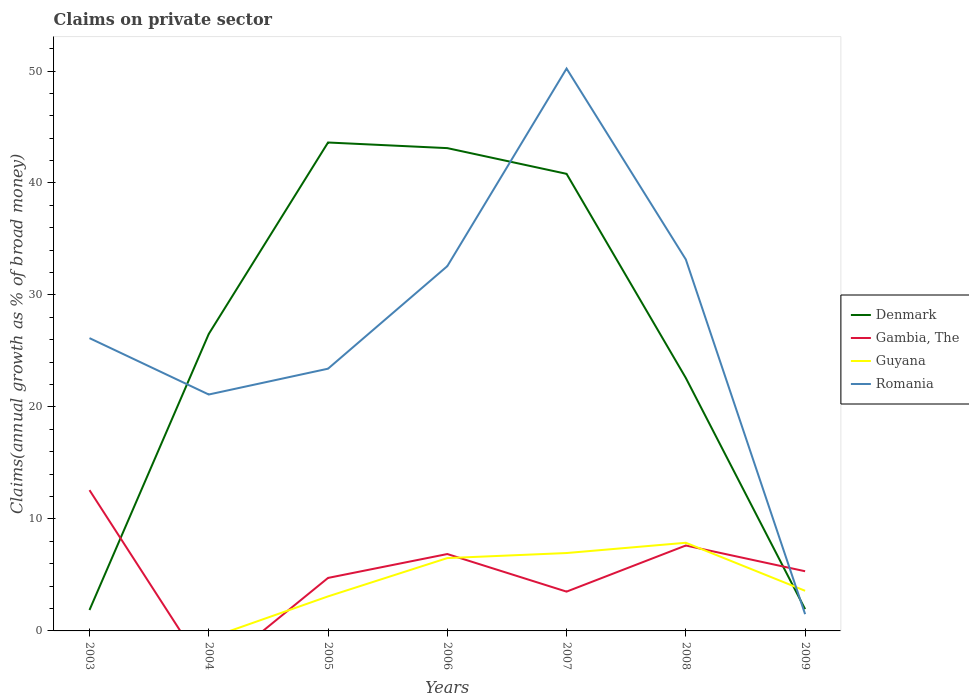Does the line corresponding to Guyana intersect with the line corresponding to Denmark?
Offer a terse response. Yes. Across all years, what is the maximum percentage of broad money claimed on private sector in Gambia, The?
Your answer should be compact. 0. What is the total percentage of broad money claimed on private sector in Denmark in the graph?
Provide a succinct answer. -17.1. What is the difference between the highest and the second highest percentage of broad money claimed on private sector in Romania?
Your answer should be very brief. 48.72. Is the percentage of broad money claimed on private sector in Guyana strictly greater than the percentage of broad money claimed on private sector in Romania over the years?
Your answer should be compact. No. How many years are there in the graph?
Give a very brief answer. 7. What is the difference between two consecutive major ticks on the Y-axis?
Provide a succinct answer. 10. Are the values on the major ticks of Y-axis written in scientific E-notation?
Your answer should be very brief. No. Does the graph contain any zero values?
Your response must be concise. Yes. Does the graph contain grids?
Your response must be concise. No. Where does the legend appear in the graph?
Provide a short and direct response. Center right. How are the legend labels stacked?
Keep it short and to the point. Vertical. What is the title of the graph?
Provide a succinct answer. Claims on private sector. What is the label or title of the Y-axis?
Your answer should be very brief. Claims(annual growth as % of broad money). What is the Claims(annual growth as % of broad money) in Denmark in 2003?
Give a very brief answer. 1.87. What is the Claims(annual growth as % of broad money) of Gambia, The in 2003?
Give a very brief answer. 12.57. What is the Claims(annual growth as % of broad money) of Romania in 2003?
Offer a very short reply. 26.15. What is the Claims(annual growth as % of broad money) of Denmark in 2004?
Offer a terse response. 26.52. What is the Claims(annual growth as % of broad money) of Romania in 2004?
Give a very brief answer. 21.11. What is the Claims(annual growth as % of broad money) of Denmark in 2005?
Ensure brevity in your answer.  43.62. What is the Claims(annual growth as % of broad money) of Gambia, The in 2005?
Ensure brevity in your answer.  4.73. What is the Claims(annual growth as % of broad money) in Guyana in 2005?
Your response must be concise. 3.08. What is the Claims(annual growth as % of broad money) of Romania in 2005?
Provide a short and direct response. 23.42. What is the Claims(annual growth as % of broad money) of Denmark in 2006?
Your response must be concise. 43.11. What is the Claims(annual growth as % of broad money) in Gambia, The in 2006?
Offer a terse response. 6.87. What is the Claims(annual growth as % of broad money) of Guyana in 2006?
Ensure brevity in your answer.  6.5. What is the Claims(annual growth as % of broad money) in Romania in 2006?
Provide a succinct answer. 32.57. What is the Claims(annual growth as % of broad money) of Denmark in 2007?
Ensure brevity in your answer.  40.82. What is the Claims(annual growth as % of broad money) in Gambia, The in 2007?
Your answer should be very brief. 3.51. What is the Claims(annual growth as % of broad money) in Guyana in 2007?
Your answer should be very brief. 6.96. What is the Claims(annual growth as % of broad money) in Romania in 2007?
Your response must be concise. 50.22. What is the Claims(annual growth as % of broad money) in Denmark in 2008?
Offer a very short reply. 22.59. What is the Claims(annual growth as % of broad money) of Gambia, The in 2008?
Offer a very short reply. 7.63. What is the Claims(annual growth as % of broad money) in Guyana in 2008?
Your response must be concise. 7.87. What is the Claims(annual growth as % of broad money) in Romania in 2008?
Offer a very short reply. 33.17. What is the Claims(annual growth as % of broad money) of Denmark in 2009?
Your answer should be compact. 1.94. What is the Claims(annual growth as % of broad money) in Gambia, The in 2009?
Your answer should be compact. 5.33. What is the Claims(annual growth as % of broad money) of Guyana in 2009?
Offer a very short reply. 3.58. What is the Claims(annual growth as % of broad money) in Romania in 2009?
Provide a short and direct response. 1.5. Across all years, what is the maximum Claims(annual growth as % of broad money) in Denmark?
Keep it short and to the point. 43.62. Across all years, what is the maximum Claims(annual growth as % of broad money) in Gambia, The?
Ensure brevity in your answer.  12.57. Across all years, what is the maximum Claims(annual growth as % of broad money) of Guyana?
Give a very brief answer. 7.87. Across all years, what is the maximum Claims(annual growth as % of broad money) in Romania?
Offer a terse response. 50.22. Across all years, what is the minimum Claims(annual growth as % of broad money) of Denmark?
Make the answer very short. 1.87. Across all years, what is the minimum Claims(annual growth as % of broad money) in Gambia, The?
Provide a succinct answer. 0. Across all years, what is the minimum Claims(annual growth as % of broad money) in Guyana?
Your response must be concise. 0. Across all years, what is the minimum Claims(annual growth as % of broad money) in Romania?
Offer a terse response. 1.5. What is the total Claims(annual growth as % of broad money) in Denmark in the graph?
Keep it short and to the point. 180.47. What is the total Claims(annual growth as % of broad money) in Gambia, The in the graph?
Provide a succinct answer. 40.64. What is the total Claims(annual growth as % of broad money) of Guyana in the graph?
Provide a short and direct response. 28. What is the total Claims(annual growth as % of broad money) of Romania in the graph?
Offer a very short reply. 188.13. What is the difference between the Claims(annual growth as % of broad money) in Denmark in 2003 and that in 2004?
Your answer should be compact. -24.65. What is the difference between the Claims(annual growth as % of broad money) in Romania in 2003 and that in 2004?
Ensure brevity in your answer.  5.04. What is the difference between the Claims(annual growth as % of broad money) of Denmark in 2003 and that in 2005?
Your answer should be very brief. -41.75. What is the difference between the Claims(annual growth as % of broad money) of Gambia, The in 2003 and that in 2005?
Offer a terse response. 7.84. What is the difference between the Claims(annual growth as % of broad money) in Romania in 2003 and that in 2005?
Offer a very short reply. 2.73. What is the difference between the Claims(annual growth as % of broad money) in Denmark in 2003 and that in 2006?
Offer a terse response. -41.25. What is the difference between the Claims(annual growth as % of broad money) in Gambia, The in 2003 and that in 2006?
Give a very brief answer. 5.71. What is the difference between the Claims(annual growth as % of broad money) of Romania in 2003 and that in 2006?
Your answer should be compact. -6.43. What is the difference between the Claims(annual growth as % of broad money) of Denmark in 2003 and that in 2007?
Offer a terse response. -38.95. What is the difference between the Claims(annual growth as % of broad money) in Gambia, The in 2003 and that in 2007?
Ensure brevity in your answer.  9.06. What is the difference between the Claims(annual growth as % of broad money) of Romania in 2003 and that in 2007?
Give a very brief answer. -24.07. What is the difference between the Claims(annual growth as % of broad money) in Denmark in 2003 and that in 2008?
Give a very brief answer. -20.72. What is the difference between the Claims(annual growth as % of broad money) in Gambia, The in 2003 and that in 2008?
Your answer should be very brief. 4.94. What is the difference between the Claims(annual growth as % of broad money) in Romania in 2003 and that in 2008?
Your response must be concise. -7.02. What is the difference between the Claims(annual growth as % of broad money) in Denmark in 2003 and that in 2009?
Give a very brief answer. -0.08. What is the difference between the Claims(annual growth as % of broad money) of Gambia, The in 2003 and that in 2009?
Provide a short and direct response. 7.24. What is the difference between the Claims(annual growth as % of broad money) in Romania in 2003 and that in 2009?
Ensure brevity in your answer.  24.65. What is the difference between the Claims(annual growth as % of broad money) of Denmark in 2004 and that in 2005?
Your answer should be compact. -17.1. What is the difference between the Claims(annual growth as % of broad money) in Romania in 2004 and that in 2005?
Keep it short and to the point. -2.31. What is the difference between the Claims(annual growth as % of broad money) in Denmark in 2004 and that in 2006?
Your answer should be very brief. -16.59. What is the difference between the Claims(annual growth as % of broad money) of Romania in 2004 and that in 2006?
Give a very brief answer. -11.46. What is the difference between the Claims(annual growth as % of broad money) in Denmark in 2004 and that in 2007?
Give a very brief answer. -14.3. What is the difference between the Claims(annual growth as % of broad money) of Romania in 2004 and that in 2007?
Give a very brief answer. -29.11. What is the difference between the Claims(annual growth as % of broad money) in Denmark in 2004 and that in 2008?
Make the answer very short. 3.93. What is the difference between the Claims(annual growth as % of broad money) in Romania in 2004 and that in 2008?
Your response must be concise. -12.06. What is the difference between the Claims(annual growth as % of broad money) of Denmark in 2004 and that in 2009?
Keep it short and to the point. 24.58. What is the difference between the Claims(annual growth as % of broad money) of Romania in 2004 and that in 2009?
Make the answer very short. 19.61. What is the difference between the Claims(annual growth as % of broad money) of Denmark in 2005 and that in 2006?
Your answer should be compact. 0.5. What is the difference between the Claims(annual growth as % of broad money) in Gambia, The in 2005 and that in 2006?
Give a very brief answer. -2.13. What is the difference between the Claims(annual growth as % of broad money) of Guyana in 2005 and that in 2006?
Your response must be concise. -3.42. What is the difference between the Claims(annual growth as % of broad money) of Romania in 2005 and that in 2006?
Offer a very short reply. -9.16. What is the difference between the Claims(annual growth as % of broad money) of Denmark in 2005 and that in 2007?
Your response must be concise. 2.8. What is the difference between the Claims(annual growth as % of broad money) of Gambia, The in 2005 and that in 2007?
Ensure brevity in your answer.  1.22. What is the difference between the Claims(annual growth as % of broad money) of Guyana in 2005 and that in 2007?
Offer a very short reply. -3.87. What is the difference between the Claims(annual growth as % of broad money) of Romania in 2005 and that in 2007?
Your answer should be very brief. -26.8. What is the difference between the Claims(annual growth as % of broad money) of Denmark in 2005 and that in 2008?
Provide a succinct answer. 21.03. What is the difference between the Claims(annual growth as % of broad money) in Gambia, The in 2005 and that in 2008?
Offer a very short reply. -2.9. What is the difference between the Claims(annual growth as % of broad money) in Guyana in 2005 and that in 2008?
Make the answer very short. -4.79. What is the difference between the Claims(annual growth as % of broad money) of Romania in 2005 and that in 2008?
Make the answer very short. -9.75. What is the difference between the Claims(annual growth as % of broad money) of Denmark in 2005 and that in 2009?
Your response must be concise. 41.67. What is the difference between the Claims(annual growth as % of broad money) in Gambia, The in 2005 and that in 2009?
Provide a succinct answer. -0.6. What is the difference between the Claims(annual growth as % of broad money) in Guyana in 2005 and that in 2009?
Your response must be concise. -0.5. What is the difference between the Claims(annual growth as % of broad money) of Romania in 2005 and that in 2009?
Provide a succinct answer. 21.92. What is the difference between the Claims(annual growth as % of broad money) of Denmark in 2006 and that in 2007?
Your answer should be very brief. 2.3. What is the difference between the Claims(annual growth as % of broad money) in Gambia, The in 2006 and that in 2007?
Give a very brief answer. 3.36. What is the difference between the Claims(annual growth as % of broad money) in Guyana in 2006 and that in 2007?
Provide a succinct answer. -0.45. What is the difference between the Claims(annual growth as % of broad money) of Romania in 2006 and that in 2007?
Your response must be concise. -17.65. What is the difference between the Claims(annual growth as % of broad money) in Denmark in 2006 and that in 2008?
Provide a succinct answer. 20.53. What is the difference between the Claims(annual growth as % of broad money) of Gambia, The in 2006 and that in 2008?
Keep it short and to the point. -0.76. What is the difference between the Claims(annual growth as % of broad money) in Guyana in 2006 and that in 2008?
Keep it short and to the point. -1.37. What is the difference between the Claims(annual growth as % of broad money) in Romania in 2006 and that in 2008?
Ensure brevity in your answer.  -0.6. What is the difference between the Claims(annual growth as % of broad money) of Denmark in 2006 and that in 2009?
Your answer should be compact. 41.17. What is the difference between the Claims(annual growth as % of broad money) in Gambia, The in 2006 and that in 2009?
Keep it short and to the point. 1.54. What is the difference between the Claims(annual growth as % of broad money) in Guyana in 2006 and that in 2009?
Offer a very short reply. 2.92. What is the difference between the Claims(annual growth as % of broad money) of Romania in 2006 and that in 2009?
Make the answer very short. 31.08. What is the difference between the Claims(annual growth as % of broad money) of Denmark in 2007 and that in 2008?
Give a very brief answer. 18.23. What is the difference between the Claims(annual growth as % of broad money) in Gambia, The in 2007 and that in 2008?
Provide a short and direct response. -4.12. What is the difference between the Claims(annual growth as % of broad money) in Guyana in 2007 and that in 2008?
Provide a succinct answer. -0.92. What is the difference between the Claims(annual growth as % of broad money) in Romania in 2007 and that in 2008?
Your answer should be compact. 17.05. What is the difference between the Claims(annual growth as % of broad money) of Denmark in 2007 and that in 2009?
Your answer should be very brief. 38.87. What is the difference between the Claims(annual growth as % of broad money) of Gambia, The in 2007 and that in 2009?
Your answer should be very brief. -1.82. What is the difference between the Claims(annual growth as % of broad money) of Guyana in 2007 and that in 2009?
Your answer should be compact. 3.37. What is the difference between the Claims(annual growth as % of broad money) in Romania in 2007 and that in 2009?
Make the answer very short. 48.72. What is the difference between the Claims(annual growth as % of broad money) of Denmark in 2008 and that in 2009?
Offer a terse response. 20.64. What is the difference between the Claims(annual growth as % of broad money) in Gambia, The in 2008 and that in 2009?
Offer a very short reply. 2.3. What is the difference between the Claims(annual growth as % of broad money) of Guyana in 2008 and that in 2009?
Offer a very short reply. 4.29. What is the difference between the Claims(annual growth as % of broad money) of Romania in 2008 and that in 2009?
Your response must be concise. 31.67. What is the difference between the Claims(annual growth as % of broad money) of Denmark in 2003 and the Claims(annual growth as % of broad money) of Romania in 2004?
Your answer should be compact. -19.24. What is the difference between the Claims(annual growth as % of broad money) in Gambia, The in 2003 and the Claims(annual growth as % of broad money) in Romania in 2004?
Give a very brief answer. -8.54. What is the difference between the Claims(annual growth as % of broad money) in Denmark in 2003 and the Claims(annual growth as % of broad money) in Gambia, The in 2005?
Provide a short and direct response. -2.86. What is the difference between the Claims(annual growth as % of broad money) of Denmark in 2003 and the Claims(annual growth as % of broad money) of Guyana in 2005?
Offer a terse response. -1.22. What is the difference between the Claims(annual growth as % of broad money) of Denmark in 2003 and the Claims(annual growth as % of broad money) of Romania in 2005?
Offer a very short reply. -21.55. What is the difference between the Claims(annual growth as % of broad money) of Gambia, The in 2003 and the Claims(annual growth as % of broad money) of Guyana in 2005?
Keep it short and to the point. 9.49. What is the difference between the Claims(annual growth as % of broad money) of Gambia, The in 2003 and the Claims(annual growth as % of broad money) of Romania in 2005?
Offer a very short reply. -10.84. What is the difference between the Claims(annual growth as % of broad money) in Denmark in 2003 and the Claims(annual growth as % of broad money) in Gambia, The in 2006?
Keep it short and to the point. -5. What is the difference between the Claims(annual growth as % of broad money) in Denmark in 2003 and the Claims(annual growth as % of broad money) in Guyana in 2006?
Make the answer very short. -4.64. What is the difference between the Claims(annual growth as % of broad money) of Denmark in 2003 and the Claims(annual growth as % of broad money) of Romania in 2006?
Offer a very short reply. -30.7. What is the difference between the Claims(annual growth as % of broad money) in Gambia, The in 2003 and the Claims(annual growth as % of broad money) in Guyana in 2006?
Provide a succinct answer. 6.07. What is the difference between the Claims(annual growth as % of broad money) of Gambia, The in 2003 and the Claims(annual growth as % of broad money) of Romania in 2006?
Your answer should be very brief. -20. What is the difference between the Claims(annual growth as % of broad money) in Denmark in 2003 and the Claims(annual growth as % of broad money) in Gambia, The in 2007?
Offer a very short reply. -1.64. What is the difference between the Claims(annual growth as % of broad money) of Denmark in 2003 and the Claims(annual growth as % of broad money) of Guyana in 2007?
Offer a terse response. -5.09. What is the difference between the Claims(annual growth as % of broad money) of Denmark in 2003 and the Claims(annual growth as % of broad money) of Romania in 2007?
Provide a short and direct response. -48.35. What is the difference between the Claims(annual growth as % of broad money) of Gambia, The in 2003 and the Claims(annual growth as % of broad money) of Guyana in 2007?
Ensure brevity in your answer.  5.62. What is the difference between the Claims(annual growth as % of broad money) of Gambia, The in 2003 and the Claims(annual growth as % of broad money) of Romania in 2007?
Offer a very short reply. -37.65. What is the difference between the Claims(annual growth as % of broad money) of Denmark in 2003 and the Claims(annual growth as % of broad money) of Gambia, The in 2008?
Ensure brevity in your answer.  -5.76. What is the difference between the Claims(annual growth as % of broad money) of Denmark in 2003 and the Claims(annual growth as % of broad money) of Guyana in 2008?
Keep it short and to the point. -6. What is the difference between the Claims(annual growth as % of broad money) of Denmark in 2003 and the Claims(annual growth as % of broad money) of Romania in 2008?
Keep it short and to the point. -31.3. What is the difference between the Claims(annual growth as % of broad money) in Gambia, The in 2003 and the Claims(annual growth as % of broad money) in Guyana in 2008?
Give a very brief answer. 4.7. What is the difference between the Claims(annual growth as % of broad money) of Gambia, The in 2003 and the Claims(annual growth as % of broad money) of Romania in 2008?
Ensure brevity in your answer.  -20.6. What is the difference between the Claims(annual growth as % of broad money) in Denmark in 2003 and the Claims(annual growth as % of broad money) in Gambia, The in 2009?
Your answer should be very brief. -3.46. What is the difference between the Claims(annual growth as % of broad money) in Denmark in 2003 and the Claims(annual growth as % of broad money) in Guyana in 2009?
Your response must be concise. -1.72. What is the difference between the Claims(annual growth as % of broad money) in Denmark in 2003 and the Claims(annual growth as % of broad money) in Romania in 2009?
Provide a succinct answer. 0.37. What is the difference between the Claims(annual growth as % of broad money) of Gambia, The in 2003 and the Claims(annual growth as % of broad money) of Guyana in 2009?
Offer a very short reply. 8.99. What is the difference between the Claims(annual growth as % of broad money) in Gambia, The in 2003 and the Claims(annual growth as % of broad money) in Romania in 2009?
Make the answer very short. 11.08. What is the difference between the Claims(annual growth as % of broad money) of Denmark in 2004 and the Claims(annual growth as % of broad money) of Gambia, The in 2005?
Keep it short and to the point. 21.79. What is the difference between the Claims(annual growth as % of broad money) of Denmark in 2004 and the Claims(annual growth as % of broad money) of Guyana in 2005?
Offer a very short reply. 23.44. What is the difference between the Claims(annual growth as % of broad money) of Denmark in 2004 and the Claims(annual growth as % of broad money) of Romania in 2005?
Your response must be concise. 3.1. What is the difference between the Claims(annual growth as % of broad money) of Denmark in 2004 and the Claims(annual growth as % of broad money) of Gambia, The in 2006?
Offer a terse response. 19.65. What is the difference between the Claims(annual growth as % of broad money) in Denmark in 2004 and the Claims(annual growth as % of broad money) in Guyana in 2006?
Ensure brevity in your answer.  20.02. What is the difference between the Claims(annual growth as % of broad money) in Denmark in 2004 and the Claims(annual growth as % of broad money) in Romania in 2006?
Keep it short and to the point. -6.05. What is the difference between the Claims(annual growth as % of broad money) of Denmark in 2004 and the Claims(annual growth as % of broad money) of Gambia, The in 2007?
Offer a terse response. 23.01. What is the difference between the Claims(annual growth as % of broad money) of Denmark in 2004 and the Claims(annual growth as % of broad money) of Guyana in 2007?
Your answer should be very brief. 19.56. What is the difference between the Claims(annual growth as % of broad money) of Denmark in 2004 and the Claims(annual growth as % of broad money) of Romania in 2007?
Keep it short and to the point. -23.7. What is the difference between the Claims(annual growth as % of broad money) of Denmark in 2004 and the Claims(annual growth as % of broad money) of Gambia, The in 2008?
Provide a succinct answer. 18.89. What is the difference between the Claims(annual growth as % of broad money) in Denmark in 2004 and the Claims(annual growth as % of broad money) in Guyana in 2008?
Offer a terse response. 18.65. What is the difference between the Claims(annual growth as % of broad money) in Denmark in 2004 and the Claims(annual growth as % of broad money) in Romania in 2008?
Offer a very short reply. -6.65. What is the difference between the Claims(annual growth as % of broad money) of Denmark in 2004 and the Claims(annual growth as % of broad money) of Gambia, The in 2009?
Ensure brevity in your answer.  21.19. What is the difference between the Claims(annual growth as % of broad money) in Denmark in 2004 and the Claims(annual growth as % of broad money) in Guyana in 2009?
Offer a very short reply. 22.94. What is the difference between the Claims(annual growth as % of broad money) in Denmark in 2004 and the Claims(annual growth as % of broad money) in Romania in 2009?
Make the answer very short. 25.02. What is the difference between the Claims(annual growth as % of broad money) of Denmark in 2005 and the Claims(annual growth as % of broad money) of Gambia, The in 2006?
Make the answer very short. 36.75. What is the difference between the Claims(annual growth as % of broad money) of Denmark in 2005 and the Claims(annual growth as % of broad money) of Guyana in 2006?
Offer a very short reply. 37.11. What is the difference between the Claims(annual growth as % of broad money) in Denmark in 2005 and the Claims(annual growth as % of broad money) in Romania in 2006?
Offer a terse response. 11.04. What is the difference between the Claims(annual growth as % of broad money) in Gambia, The in 2005 and the Claims(annual growth as % of broad money) in Guyana in 2006?
Offer a terse response. -1.77. What is the difference between the Claims(annual growth as % of broad money) in Gambia, The in 2005 and the Claims(annual growth as % of broad money) in Romania in 2006?
Keep it short and to the point. -27.84. What is the difference between the Claims(annual growth as % of broad money) in Guyana in 2005 and the Claims(annual growth as % of broad money) in Romania in 2006?
Your answer should be very brief. -29.49. What is the difference between the Claims(annual growth as % of broad money) in Denmark in 2005 and the Claims(annual growth as % of broad money) in Gambia, The in 2007?
Your response must be concise. 40.11. What is the difference between the Claims(annual growth as % of broad money) of Denmark in 2005 and the Claims(annual growth as % of broad money) of Guyana in 2007?
Keep it short and to the point. 36.66. What is the difference between the Claims(annual growth as % of broad money) in Denmark in 2005 and the Claims(annual growth as % of broad money) in Romania in 2007?
Offer a terse response. -6.6. What is the difference between the Claims(annual growth as % of broad money) in Gambia, The in 2005 and the Claims(annual growth as % of broad money) in Guyana in 2007?
Keep it short and to the point. -2.22. What is the difference between the Claims(annual growth as % of broad money) of Gambia, The in 2005 and the Claims(annual growth as % of broad money) of Romania in 2007?
Provide a short and direct response. -45.49. What is the difference between the Claims(annual growth as % of broad money) in Guyana in 2005 and the Claims(annual growth as % of broad money) in Romania in 2007?
Provide a succinct answer. -47.14. What is the difference between the Claims(annual growth as % of broad money) in Denmark in 2005 and the Claims(annual growth as % of broad money) in Gambia, The in 2008?
Your answer should be very brief. 35.99. What is the difference between the Claims(annual growth as % of broad money) in Denmark in 2005 and the Claims(annual growth as % of broad money) in Guyana in 2008?
Give a very brief answer. 35.74. What is the difference between the Claims(annual growth as % of broad money) of Denmark in 2005 and the Claims(annual growth as % of broad money) of Romania in 2008?
Offer a terse response. 10.45. What is the difference between the Claims(annual growth as % of broad money) in Gambia, The in 2005 and the Claims(annual growth as % of broad money) in Guyana in 2008?
Provide a short and direct response. -3.14. What is the difference between the Claims(annual growth as % of broad money) of Gambia, The in 2005 and the Claims(annual growth as % of broad money) of Romania in 2008?
Your answer should be very brief. -28.44. What is the difference between the Claims(annual growth as % of broad money) in Guyana in 2005 and the Claims(annual growth as % of broad money) in Romania in 2008?
Give a very brief answer. -30.09. What is the difference between the Claims(annual growth as % of broad money) of Denmark in 2005 and the Claims(annual growth as % of broad money) of Gambia, The in 2009?
Provide a short and direct response. 38.29. What is the difference between the Claims(annual growth as % of broad money) in Denmark in 2005 and the Claims(annual growth as % of broad money) in Guyana in 2009?
Offer a terse response. 40.03. What is the difference between the Claims(annual growth as % of broad money) of Denmark in 2005 and the Claims(annual growth as % of broad money) of Romania in 2009?
Provide a short and direct response. 42.12. What is the difference between the Claims(annual growth as % of broad money) in Gambia, The in 2005 and the Claims(annual growth as % of broad money) in Guyana in 2009?
Your answer should be very brief. 1.15. What is the difference between the Claims(annual growth as % of broad money) in Gambia, The in 2005 and the Claims(annual growth as % of broad money) in Romania in 2009?
Ensure brevity in your answer.  3.24. What is the difference between the Claims(annual growth as % of broad money) of Guyana in 2005 and the Claims(annual growth as % of broad money) of Romania in 2009?
Make the answer very short. 1.59. What is the difference between the Claims(annual growth as % of broad money) of Denmark in 2006 and the Claims(annual growth as % of broad money) of Gambia, The in 2007?
Your answer should be very brief. 39.6. What is the difference between the Claims(annual growth as % of broad money) of Denmark in 2006 and the Claims(annual growth as % of broad money) of Guyana in 2007?
Ensure brevity in your answer.  36.16. What is the difference between the Claims(annual growth as % of broad money) of Denmark in 2006 and the Claims(annual growth as % of broad money) of Romania in 2007?
Offer a terse response. -7.11. What is the difference between the Claims(annual growth as % of broad money) in Gambia, The in 2006 and the Claims(annual growth as % of broad money) in Guyana in 2007?
Provide a succinct answer. -0.09. What is the difference between the Claims(annual growth as % of broad money) in Gambia, The in 2006 and the Claims(annual growth as % of broad money) in Romania in 2007?
Offer a very short reply. -43.35. What is the difference between the Claims(annual growth as % of broad money) of Guyana in 2006 and the Claims(annual growth as % of broad money) of Romania in 2007?
Your answer should be compact. -43.72. What is the difference between the Claims(annual growth as % of broad money) of Denmark in 2006 and the Claims(annual growth as % of broad money) of Gambia, The in 2008?
Provide a short and direct response. 35.49. What is the difference between the Claims(annual growth as % of broad money) of Denmark in 2006 and the Claims(annual growth as % of broad money) of Guyana in 2008?
Keep it short and to the point. 35.24. What is the difference between the Claims(annual growth as % of broad money) in Denmark in 2006 and the Claims(annual growth as % of broad money) in Romania in 2008?
Your answer should be compact. 9.95. What is the difference between the Claims(annual growth as % of broad money) of Gambia, The in 2006 and the Claims(annual growth as % of broad money) of Guyana in 2008?
Provide a short and direct response. -1.01. What is the difference between the Claims(annual growth as % of broad money) of Gambia, The in 2006 and the Claims(annual growth as % of broad money) of Romania in 2008?
Offer a very short reply. -26.3. What is the difference between the Claims(annual growth as % of broad money) of Guyana in 2006 and the Claims(annual growth as % of broad money) of Romania in 2008?
Ensure brevity in your answer.  -26.66. What is the difference between the Claims(annual growth as % of broad money) of Denmark in 2006 and the Claims(annual growth as % of broad money) of Gambia, The in 2009?
Give a very brief answer. 37.78. What is the difference between the Claims(annual growth as % of broad money) of Denmark in 2006 and the Claims(annual growth as % of broad money) of Guyana in 2009?
Offer a very short reply. 39.53. What is the difference between the Claims(annual growth as % of broad money) of Denmark in 2006 and the Claims(annual growth as % of broad money) of Romania in 2009?
Ensure brevity in your answer.  41.62. What is the difference between the Claims(annual growth as % of broad money) in Gambia, The in 2006 and the Claims(annual growth as % of broad money) in Guyana in 2009?
Ensure brevity in your answer.  3.28. What is the difference between the Claims(annual growth as % of broad money) of Gambia, The in 2006 and the Claims(annual growth as % of broad money) of Romania in 2009?
Provide a short and direct response. 5.37. What is the difference between the Claims(annual growth as % of broad money) in Guyana in 2006 and the Claims(annual growth as % of broad money) in Romania in 2009?
Give a very brief answer. 5.01. What is the difference between the Claims(annual growth as % of broad money) of Denmark in 2007 and the Claims(annual growth as % of broad money) of Gambia, The in 2008?
Your answer should be compact. 33.19. What is the difference between the Claims(annual growth as % of broad money) of Denmark in 2007 and the Claims(annual growth as % of broad money) of Guyana in 2008?
Your answer should be compact. 32.95. What is the difference between the Claims(annual growth as % of broad money) of Denmark in 2007 and the Claims(annual growth as % of broad money) of Romania in 2008?
Keep it short and to the point. 7.65. What is the difference between the Claims(annual growth as % of broad money) in Gambia, The in 2007 and the Claims(annual growth as % of broad money) in Guyana in 2008?
Your answer should be compact. -4.36. What is the difference between the Claims(annual growth as % of broad money) of Gambia, The in 2007 and the Claims(annual growth as % of broad money) of Romania in 2008?
Your response must be concise. -29.66. What is the difference between the Claims(annual growth as % of broad money) in Guyana in 2007 and the Claims(annual growth as % of broad money) in Romania in 2008?
Offer a very short reply. -26.21. What is the difference between the Claims(annual growth as % of broad money) in Denmark in 2007 and the Claims(annual growth as % of broad money) in Gambia, The in 2009?
Your answer should be compact. 35.49. What is the difference between the Claims(annual growth as % of broad money) in Denmark in 2007 and the Claims(annual growth as % of broad money) in Guyana in 2009?
Make the answer very short. 37.23. What is the difference between the Claims(annual growth as % of broad money) in Denmark in 2007 and the Claims(annual growth as % of broad money) in Romania in 2009?
Offer a terse response. 39.32. What is the difference between the Claims(annual growth as % of broad money) of Gambia, The in 2007 and the Claims(annual growth as % of broad money) of Guyana in 2009?
Make the answer very short. -0.07. What is the difference between the Claims(annual growth as % of broad money) in Gambia, The in 2007 and the Claims(annual growth as % of broad money) in Romania in 2009?
Your answer should be compact. 2.01. What is the difference between the Claims(annual growth as % of broad money) in Guyana in 2007 and the Claims(annual growth as % of broad money) in Romania in 2009?
Give a very brief answer. 5.46. What is the difference between the Claims(annual growth as % of broad money) in Denmark in 2008 and the Claims(annual growth as % of broad money) in Gambia, The in 2009?
Keep it short and to the point. 17.26. What is the difference between the Claims(annual growth as % of broad money) of Denmark in 2008 and the Claims(annual growth as % of broad money) of Guyana in 2009?
Give a very brief answer. 19. What is the difference between the Claims(annual growth as % of broad money) of Denmark in 2008 and the Claims(annual growth as % of broad money) of Romania in 2009?
Give a very brief answer. 21.09. What is the difference between the Claims(annual growth as % of broad money) of Gambia, The in 2008 and the Claims(annual growth as % of broad money) of Guyana in 2009?
Provide a short and direct response. 4.04. What is the difference between the Claims(annual growth as % of broad money) of Gambia, The in 2008 and the Claims(annual growth as % of broad money) of Romania in 2009?
Make the answer very short. 6.13. What is the difference between the Claims(annual growth as % of broad money) of Guyana in 2008 and the Claims(annual growth as % of broad money) of Romania in 2009?
Your answer should be very brief. 6.38. What is the average Claims(annual growth as % of broad money) in Denmark per year?
Offer a terse response. 25.78. What is the average Claims(annual growth as % of broad money) in Gambia, The per year?
Make the answer very short. 5.81. What is the average Claims(annual growth as % of broad money) in Guyana per year?
Provide a succinct answer. 4. What is the average Claims(annual growth as % of broad money) of Romania per year?
Keep it short and to the point. 26.88. In the year 2003, what is the difference between the Claims(annual growth as % of broad money) of Denmark and Claims(annual growth as % of broad money) of Gambia, The?
Make the answer very short. -10.7. In the year 2003, what is the difference between the Claims(annual growth as % of broad money) in Denmark and Claims(annual growth as % of broad money) in Romania?
Your answer should be compact. -24.28. In the year 2003, what is the difference between the Claims(annual growth as % of broad money) of Gambia, The and Claims(annual growth as % of broad money) of Romania?
Ensure brevity in your answer.  -13.57. In the year 2004, what is the difference between the Claims(annual growth as % of broad money) of Denmark and Claims(annual growth as % of broad money) of Romania?
Your answer should be very brief. 5.41. In the year 2005, what is the difference between the Claims(annual growth as % of broad money) of Denmark and Claims(annual growth as % of broad money) of Gambia, The?
Your answer should be compact. 38.88. In the year 2005, what is the difference between the Claims(annual growth as % of broad money) of Denmark and Claims(annual growth as % of broad money) of Guyana?
Provide a succinct answer. 40.53. In the year 2005, what is the difference between the Claims(annual growth as % of broad money) in Denmark and Claims(annual growth as % of broad money) in Romania?
Ensure brevity in your answer.  20.2. In the year 2005, what is the difference between the Claims(annual growth as % of broad money) in Gambia, The and Claims(annual growth as % of broad money) in Guyana?
Offer a terse response. 1.65. In the year 2005, what is the difference between the Claims(annual growth as % of broad money) in Gambia, The and Claims(annual growth as % of broad money) in Romania?
Your response must be concise. -18.68. In the year 2005, what is the difference between the Claims(annual growth as % of broad money) of Guyana and Claims(annual growth as % of broad money) of Romania?
Your response must be concise. -20.33. In the year 2006, what is the difference between the Claims(annual growth as % of broad money) in Denmark and Claims(annual growth as % of broad money) in Gambia, The?
Your answer should be very brief. 36.25. In the year 2006, what is the difference between the Claims(annual growth as % of broad money) of Denmark and Claims(annual growth as % of broad money) of Guyana?
Provide a succinct answer. 36.61. In the year 2006, what is the difference between the Claims(annual growth as % of broad money) of Denmark and Claims(annual growth as % of broad money) of Romania?
Your answer should be very brief. 10.54. In the year 2006, what is the difference between the Claims(annual growth as % of broad money) of Gambia, The and Claims(annual growth as % of broad money) of Guyana?
Provide a short and direct response. 0.36. In the year 2006, what is the difference between the Claims(annual growth as % of broad money) in Gambia, The and Claims(annual growth as % of broad money) in Romania?
Keep it short and to the point. -25.71. In the year 2006, what is the difference between the Claims(annual growth as % of broad money) in Guyana and Claims(annual growth as % of broad money) in Romania?
Provide a short and direct response. -26.07. In the year 2007, what is the difference between the Claims(annual growth as % of broad money) of Denmark and Claims(annual growth as % of broad money) of Gambia, The?
Your answer should be very brief. 37.31. In the year 2007, what is the difference between the Claims(annual growth as % of broad money) in Denmark and Claims(annual growth as % of broad money) in Guyana?
Provide a short and direct response. 33.86. In the year 2007, what is the difference between the Claims(annual growth as % of broad money) in Denmark and Claims(annual growth as % of broad money) in Romania?
Keep it short and to the point. -9.4. In the year 2007, what is the difference between the Claims(annual growth as % of broad money) in Gambia, The and Claims(annual growth as % of broad money) in Guyana?
Provide a succinct answer. -3.45. In the year 2007, what is the difference between the Claims(annual growth as % of broad money) of Gambia, The and Claims(annual growth as % of broad money) of Romania?
Your response must be concise. -46.71. In the year 2007, what is the difference between the Claims(annual growth as % of broad money) in Guyana and Claims(annual growth as % of broad money) in Romania?
Ensure brevity in your answer.  -43.26. In the year 2008, what is the difference between the Claims(annual growth as % of broad money) of Denmark and Claims(annual growth as % of broad money) of Gambia, The?
Offer a terse response. 14.96. In the year 2008, what is the difference between the Claims(annual growth as % of broad money) in Denmark and Claims(annual growth as % of broad money) in Guyana?
Provide a short and direct response. 14.71. In the year 2008, what is the difference between the Claims(annual growth as % of broad money) in Denmark and Claims(annual growth as % of broad money) in Romania?
Keep it short and to the point. -10.58. In the year 2008, what is the difference between the Claims(annual growth as % of broad money) in Gambia, The and Claims(annual growth as % of broad money) in Guyana?
Make the answer very short. -0.24. In the year 2008, what is the difference between the Claims(annual growth as % of broad money) of Gambia, The and Claims(annual growth as % of broad money) of Romania?
Make the answer very short. -25.54. In the year 2008, what is the difference between the Claims(annual growth as % of broad money) in Guyana and Claims(annual growth as % of broad money) in Romania?
Your response must be concise. -25.3. In the year 2009, what is the difference between the Claims(annual growth as % of broad money) in Denmark and Claims(annual growth as % of broad money) in Gambia, The?
Give a very brief answer. -3.38. In the year 2009, what is the difference between the Claims(annual growth as % of broad money) in Denmark and Claims(annual growth as % of broad money) in Guyana?
Provide a succinct answer. -1.64. In the year 2009, what is the difference between the Claims(annual growth as % of broad money) in Denmark and Claims(annual growth as % of broad money) in Romania?
Keep it short and to the point. 0.45. In the year 2009, what is the difference between the Claims(annual growth as % of broad money) in Gambia, The and Claims(annual growth as % of broad money) in Guyana?
Your response must be concise. 1.75. In the year 2009, what is the difference between the Claims(annual growth as % of broad money) in Gambia, The and Claims(annual growth as % of broad money) in Romania?
Your answer should be compact. 3.83. In the year 2009, what is the difference between the Claims(annual growth as % of broad money) in Guyana and Claims(annual growth as % of broad money) in Romania?
Provide a short and direct response. 2.09. What is the ratio of the Claims(annual growth as % of broad money) in Denmark in 2003 to that in 2004?
Give a very brief answer. 0.07. What is the ratio of the Claims(annual growth as % of broad money) of Romania in 2003 to that in 2004?
Give a very brief answer. 1.24. What is the ratio of the Claims(annual growth as % of broad money) of Denmark in 2003 to that in 2005?
Give a very brief answer. 0.04. What is the ratio of the Claims(annual growth as % of broad money) in Gambia, The in 2003 to that in 2005?
Your response must be concise. 2.66. What is the ratio of the Claims(annual growth as % of broad money) in Romania in 2003 to that in 2005?
Your response must be concise. 1.12. What is the ratio of the Claims(annual growth as % of broad money) in Denmark in 2003 to that in 2006?
Give a very brief answer. 0.04. What is the ratio of the Claims(annual growth as % of broad money) in Gambia, The in 2003 to that in 2006?
Your answer should be very brief. 1.83. What is the ratio of the Claims(annual growth as % of broad money) of Romania in 2003 to that in 2006?
Give a very brief answer. 0.8. What is the ratio of the Claims(annual growth as % of broad money) of Denmark in 2003 to that in 2007?
Ensure brevity in your answer.  0.05. What is the ratio of the Claims(annual growth as % of broad money) of Gambia, The in 2003 to that in 2007?
Offer a terse response. 3.58. What is the ratio of the Claims(annual growth as % of broad money) in Romania in 2003 to that in 2007?
Your response must be concise. 0.52. What is the ratio of the Claims(annual growth as % of broad money) of Denmark in 2003 to that in 2008?
Offer a very short reply. 0.08. What is the ratio of the Claims(annual growth as % of broad money) in Gambia, The in 2003 to that in 2008?
Your response must be concise. 1.65. What is the ratio of the Claims(annual growth as % of broad money) in Romania in 2003 to that in 2008?
Offer a very short reply. 0.79. What is the ratio of the Claims(annual growth as % of broad money) in Denmark in 2003 to that in 2009?
Your answer should be very brief. 0.96. What is the ratio of the Claims(annual growth as % of broad money) of Gambia, The in 2003 to that in 2009?
Your answer should be compact. 2.36. What is the ratio of the Claims(annual growth as % of broad money) of Romania in 2003 to that in 2009?
Your answer should be very brief. 17.47. What is the ratio of the Claims(annual growth as % of broad money) of Denmark in 2004 to that in 2005?
Give a very brief answer. 0.61. What is the ratio of the Claims(annual growth as % of broad money) of Romania in 2004 to that in 2005?
Provide a succinct answer. 0.9. What is the ratio of the Claims(annual growth as % of broad money) in Denmark in 2004 to that in 2006?
Make the answer very short. 0.62. What is the ratio of the Claims(annual growth as % of broad money) in Romania in 2004 to that in 2006?
Your response must be concise. 0.65. What is the ratio of the Claims(annual growth as % of broad money) in Denmark in 2004 to that in 2007?
Make the answer very short. 0.65. What is the ratio of the Claims(annual growth as % of broad money) of Romania in 2004 to that in 2007?
Make the answer very short. 0.42. What is the ratio of the Claims(annual growth as % of broad money) in Denmark in 2004 to that in 2008?
Keep it short and to the point. 1.17. What is the ratio of the Claims(annual growth as % of broad money) of Romania in 2004 to that in 2008?
Your answer should be compact. 0.64. What is the ratio of the Claims(annual growth as % of broad money) of Denmark in 2004 to that in 2009?
Offer a very short reply. 13.64. What is the ratio of the Claims(annual growth as % of broad money) of Romania in 2004 to that in 2009?
Make the answer very short. 14.1. What is the ratio of the Claims(annual growth as % of broad money) in Denmark in 2005 to that in 2006?
Make the answer very short. 1.01. What is the ratio of the Claims(annual growth as % of broad money) in Gambia, The in 2005 to that in 2006?
Make the answer very short. 0.69. What is the ratio of the Claims(annual growth as % of broad money) of Guyana in 2005 to that in 2006?
Offer a very short reply. 0.47. What is the ratio of the Claims(annual growth as % of broad money) of Romania in 2005 to that in 2006?
Provide a succinct answer. 0.72. What is the ratio of the Claims(annual growth as % of broad money) of Denmark in 2005 to that in 2007?
Make the answer very short. 1.07. What is the ratio of the Claims(annual growth as % of broad money) in Gambia, The in 2005 to that in 2007?
Keep it short and to the point. 1.35. What is the ratio of the Claims(annual growth as % of broad money) in Guyana in 2005 to that in 2007?
Provide a succinct answer. 0.44. What is the ratio of the Claims(annual growth as % of broad money) in Romania in 2005 to that in 2007?
Your answer should be compact. 0.47. What is the ratio of the Claims(annual growth as % of broad money) in Denmark in 2005 to that in 2008?
Provide a short and direct response. 1.93. What is the ratio of the Claims(annual growth as % of broad money) of Gambia, The in 2005 to that in 2008?
Keep it short and to the point. 0.62. What is the ratio of the Claims(annual growth as % of broad money) of Guyana in 2005 to that in 2008?
Make the answer very short. 0.39. What is the ratio of the Claims(annual growth as % of broad money) in Romania in 2005 to that in 2008?
Your response must be concise. 0.71. What is the ratio of the Claims(annual growth as % of broad money) of Denmark in 2005 to that in 2009?
Provide a short and direct response. 22.43. What is the ratio of the Claims(annual growth as % of broad money) of Gambia, The in 2005 to that in 2009?
Keep it short and to the point. 0.89. What is the ratio of the Claims(annual growth as % of broad money) in Guyana in 2005 to that in 2009?
Your response must be concise. 0.86. What is the ratio of the Claims(annual growth as % of broad money) in Romania in 2005 to that in 2009?
Make the answer very short. 15.64. What is the ratio of the Claims(annual growth as % of broad money) in Denmark in 2006 to that in 2007?
Provide a succinct answer. 1.06. What is the ratio of the Claims(annual growth as % of broad money) in Gambia, The in 2006 to that in 2007?
Keep it short and to the point. 1.96. What is the ratio of the Claims(annual growth as % of broad money) in Guyana in 2006 to that in 2007?
Offer a terse response. 0.94. What is the ratio of the Claims(annual growth as % of broad money) of Romania in 2006 to that in 2007?
Ensure brevity in your answer.  0.65. What is the ratio of the Claims(annual growth as % of broad money) of Denmark in 2006 to that in 2008?
Offer a terse response. 1.91. What is the ratio of the Claims(annual growth as % of broad money) of Guyana in 2006 to that in 2008?
Provide a short and direct response. 0.83. What is the ratio of the Claims(annual growth as % of broad money) in Romania in 2006 to that in 2008?
Give a very brief answer. 0.98. What is the ratio of the Claims(annual growth as % of broad money) of Denmark in 2006 to that in 2009?
Offer a very short reply. 22.17. What is the ratio of the Claims(annual growth as % of broad money) in Gambia, The in 2006 to that in 2009?
Your response must be concise. 1.29. What is the ratio of the Claims(annual growth as % of broad money) in Guyana in 2006 to that in 2009?
Ensure brevity in your answer.  1.81. What is the ratio of the Claims(annual growth as % of broad money) of Romania in 2006 to that in 2009?
Offer a terse response. 21.76. What is the ratio of the Claims(annual growth as % of broad money) in Denmark in 2007 to that in 2008?
Your answer should be compact. 1.81. What is the ratio of the Claims(annual growth as % of broad money) in Gambia, The in 2007 to that in 2008?
Keep it short and to the point. 0.46. What is the ratio of the Claims(annual growth as % of broad money) in Guyana in 2007 to that in 2008?
Provide a short and direct response. 0.88. What is the ratio of the Claims(annual growth as % of broad money) in Romania in 2007 to that in 2008?
Keep it short and to the point. 1.51. What is the ratio of the Claims(annual growth as % of broad money) of Denmark in 2007 to that in 2009?
Provide a short and direct response. 20.99. What is the ratio of the Claims(annual growth as % of broad money) in Gambia, The in 2007 to that in 2009?
Keep it short and to the point. 0.66. What is the ratio of the Claims(annual growth as % of broad money) in Guyana in 2007 to that in 2009?
Give a very brief answer. 1.94. What is the ratio of the Claims(annual growth as % of broad money) in Romania in 2007 to that in 2009?
Your response must be concise. 33.55. What is the ratio of the Claims(annual growth as % of broad money) in Denmark in 2008 to that in 2009?
Your answer should be compact. 11.61. What is the ratio of the Claims(annual growth as % of broad money) in Gambia, The in 2008 to that in 2009?
Keep it short and to the point. 1.43. What is the ratio of the Claims(annual growth as % of broad money) of Guyana in 2008 to that in 2009?
Give a very brief answer. 2.2. What is the ratio of the Claims(annual growth as % of broad money) in Romania in 2008 to that in 2009?
Provide a short and direct response. 22.16. What is the difference between the highest and the second highest Claims(annual growth as % of broad money) of Denmark?
Make the answer very short. 0.5. What is the difference between the highest and the second highest Claims(annual growth as % of broad money) of Gambia, The?
Your answer should be compact. 4.94. What is the difference between the highest and the second highest Claims(annual growth as % of broad money) in Guyana?
Give a very brief answer. 0.92. What is the difference between the highest and the second highest Claims(annual growth as % of broad money) in Romania?
Ensure brevity in your answer.  17.05. What is the difference between the highest and the lowest Claims(annual growth as % of broad money) in Denmark?
Offer a terse response. 41.75. What is the difference between the highest and the lowest Claims(annual growth as % of broad money) in Gambia, The?
Your response must be concise. 12.57. What is the difference between the highest and the lowest Claims(annual growth as % of broad money) in Guyana?
Offer a very short reply. 7.87. What is the difference between the highest and the lowest Claims(annual growth as % of broad money) of Romania?
Provide a short and direct response. 48.72. 